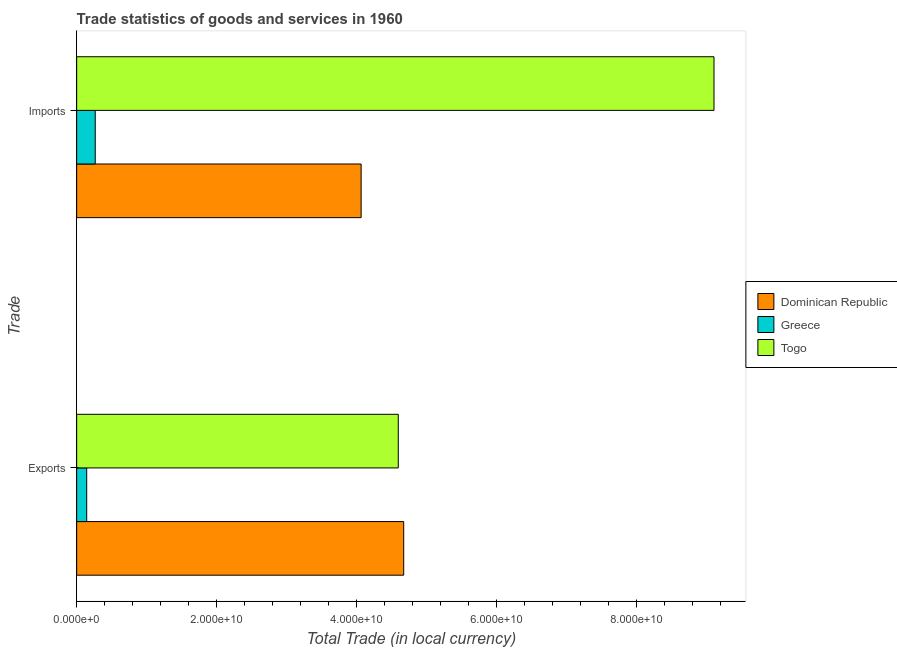How many groups of bars are there?
Offer a very short reply. 2. Are the number of bars on each tick of the Y-axis equal?
Your response must be concise. Yes. How many bars are there on the 2nd tick from the top?
Provide a succinct answer. 3. What is the label of the 2nd group of bars from the top?
Your answer should be very brief. Exports. What is the export of goods and services in Greece?
Provide a short and direct response. 1.43e+09. Across all countries, what is the maximum export of goods and services?
Your answer should be very brief. 4.67e+1. Across all countries, what is the minimum imports of goods and services?
Make the answer very short. 2.65e+09. In which country was the export of goods and services maximum?
Give a very brief answer. Dominican Republic. What is the total imports of goods and services in the graph?
Provide a succinct answer. 1.34e+11. What is the difference between the export of goods and services in Togo and that in Greece?
Provide a short and direct response. 4.45e+1. What is the difference between the imports of goods and services in Togo and the export of goods and services in Dominican Republic?
Provide a short and direct response. 4.43e+1. What is the average export of goods and services per country?
Provide a short and direct response. 3.14e+1. What is the difference between the export of goods and services and imports of goods and services in Togo?
Make the answer very short. -4.51e+1. What is the ratio of the export of goods and services in Dominican Republic to that in Greece?
Provide a succinct answer. 32.55. Is the imports of goods and services in Togo less than that in Dominican Republic?
Provide a short and direct response. No. What does the 2nd bar from the top in Imports represents?
Offer a terse response. Greece. What does the 1st bar from the bottom in Exports represents?
Keep it short and to the point. Dominican Republic. How many bars are there?
Offer a terse response. 6. How many countries are there in the graph?
Make the answer very short. 3. What is the difference between two consecutive major ticks on the X-axis?
Offer a very short reply. 2.00e+1. Are the values on the major ticks of X-axis written in scientific E-notation?
Provide a short and direct response. Yes. Does the graph contain grids?
Offer a terse response. No. How are the legend labels stacked?
Your response must be concise. Vertical. What is the title of the graph?
Make the answer very short. Trade statistics of goods and services in 1960. Does "Germany" appear as one of the legend labels in the graph?
Provide a short and direct response. No. What is the label or title of the X-axis?
Offer a terse response. Total Trade (in local currency). What is the label or title of the Y-axis?
Offer a very short reply. Trade. What is the Total Trade (in local currency) of Dominican Republic in Exports?
Your answer should be compact. 4.67e+1. What is the Total Trade (in local currency) of Greece in Exports?
Provide a succinct answer. 1.43e+09. What is the Total Trade (in local currency) in Togo in Exports?
Give a very brief answer. 4.59e+1. What is the Total Trade (in local currency) of Dominican Republic in Imports?
Keep it short and to the point. 4.06e+1. What is the Total Trade (in local currency) in Greece in Imports?
Keep it short and to the point. 2.65e+09. What is the Total Trade (in local currency) of Togo in Imports?
Provide a short and direct response. 9.10e+1. Across all Trade, what is the maximum Total Trade (in local currency) of Dominican Republic?
Your answer should be very brief. 4.67e+1. Across all Trade, what is the maximum Total Trade (in local currency) of Greece?
Offer a very short reply. 2.65e+09. Across all Trade, what is the maximum Total Trade (in local currency) of Togo?
Offer a very short reply. 9.10e+1. Across all Trade, what is the minimum Total Trade (in local currency) of Dominican Republic?
Your response must be concise. 4.06e+1. Across all Trade, what is the minimum Total Trade (in local currency) of Greece?
Make the answer very short. 1.43e+09. Across all Trade, what is the minimum Total Trade (in local currency) in Togo?
Make the answer very short. 4.59e+1. What is the total Total Trade (in local currency) of Dominican Republic in the graph?
Your answer should be very brief. 8.73e+1. What is the total Total Trade (in local currency) in Greece in the graph?
Provide a short and direct response. 4.09e+09. What is the total Total Trade (in local currency) in Togo in the graph?
Keep it short and to the point. 1.37e+11. What is the difference between the Total Trade (in local currency) of Dominican Republic in Exports and that in Imports?
Offer a very short reply. 6.08e+09. What is the difference between the Total Trade (in local currency) of Greece in Exports and that in Imports?
Provide a short and direct response. -1.22e+09. What is the difference between the Total Trade (in local currency) of Togo in Exports and that in Imports?
Your response must be concise. -4.51e+1. What is the difference between the Total Trade (in local currency) of Dominican Republic in Exports and the Total Trade (in local currency) of Greece in Imports?
Provide a succinct answer. 4.41e+1. What is the difference between the Total Trade (in local currency) in Dominican Republic in Exports and the Total Trade (in local currency) in Togo in Imports?
Offer a very short reply. -4.43e+1. What is the difference between the Total Trade (in local currency) of Greece in Exports and the Total Trade (in local currency) of Togo in Imports?
Provide a succinct answer. -8.96e+1. What is the average Total Trade (in local currency) in Dominican Republic per Trade?
Give a very brief answer. 4.37e+1. What is the average Total Trade (in local currency) in Greece per Trade?
Your answer should be very brief. 2.04e+09. What is the average Total Trade (in local currency) in Togo per Trade?
Keep it short and to the point. 6.85e+1. What is the difference between the Total Trade (in local currency) in Dominican Republic and Total Trade (in local currency) in Greece in Exports?
Give a very brief answer. 4.53e+1. What is the difference between the Total Trade (in local currency) in Dominican Republic and Total Trade (in local currency) in Togo in Exports?
Make the answer very short. 7.73e+08. What is the difference between the Total Trade (in local currency) of Greece and Total Trade (in local currency) of Togo in Exports?
Your answer should be very brief. -4.45e+1. What is the difference between the Total Trade (in local currency) in Dominican Republic and Total Trade (in local currency) in Greece in Imports?
Offer a terse response. 3.80e+1. What is the difference between the Total Trade (in local currency) in Dominican Republic and Total Trade (in local currency) in Togo in Imports?
Keep it short and to the point. -5.04e+1. What is the difference between the Total Trade (in local currency) in Greece and Total Trade (in local currency) in Togo in Imports?
Ensure brevity in your answer.  -8.84e+1. What is the ratio of the Total Trade (in local currency) of Dominican Republic in Exports to that in Imports?
Offer a very short reply. 1.15. What is the ratio of the Total Trade (in local currency) in Greece in Exports to that in Imports?
Offer a very short reply. 0.54. What is the ratio of the Total Trade (in local currency) in Togo in Exports to that in Imports?
Give a very brief answer. 0.5. What is the difference between the highest and the second highest Total Trade (in local currency) in Dominican Republic?
Your response must be concise. 6.08e+09. What is the difference between the highest and the second highest Total Trade (in local currency) in Greece?
Your answer should be very brief. 1.22e+09. What is the difference between the highest and the second highest Total Trade (in local currency) of Togo?
Ensure brevity in your answer.  4.51e+1. What is the difference between the highest and the lowest Total Trade (in local currency) in Dominican Republic?
Make the answer very short. 6.08e+09. What is the difference between the highest and the lowest Total Trade (in local currency) in Greece?
Ensure brevity in your answer.  1.22e+09. What is the difference between the highest and the lowest Total Trade (in local currency) in Togo?
Your response must be concise. 4.51e+1. 